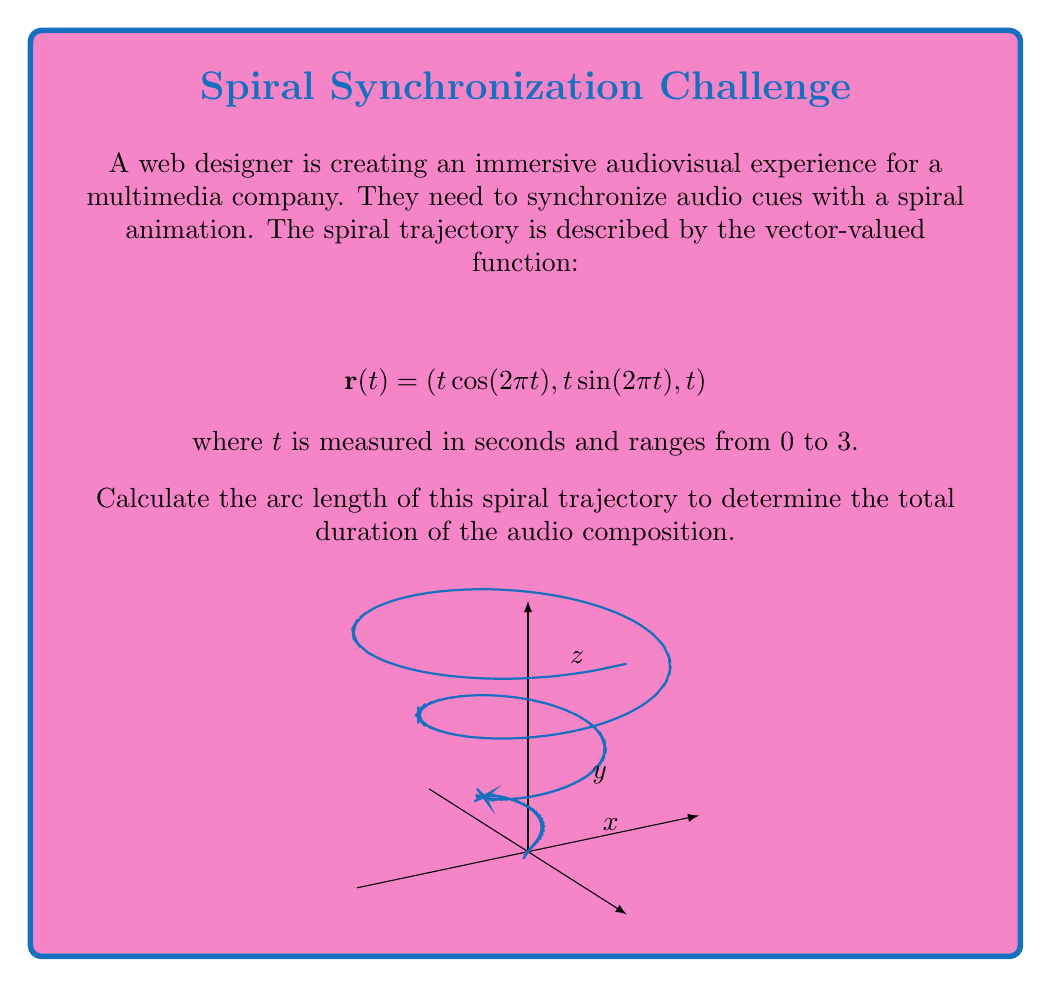Show me your answer to this math problem. To compute the arc length of a vector-valued function, we use the formula:

$$L = \int_a^b \left|\left|\frac{d\mathbf{r}}{dt}\right|\right| dt$$

where $\frac{d\mathbf{r}}{dt}$ is the derivative of the vector-valued function.

Step 1: Calculate $\frac{d\mathbf{r}}{dt}$
$$\frac{d\mathbf{r}}{dt} = (\cos(2\pi t) - 2\pi t \sin(2\pi t), \sin(2\pi t) + 2\pi t \cos(2\pi t), 1)$$

Step 2: Calculate $\left|\left|\frac{d\mathbf{r}}{dt}\right|\right|$
$$\left|\left|\frac{d\mathbf{r}}{dt}\right|\right| = \sqrt{(\cos(2\pi t) - 2\pi t \sin(2\pi t))^2 + (\sin(2\pi t) + 2\pi t \cos(2\pi t))^2 + 1^2}$$

Step 3: Simplify the expression under the square root
$$\left|\left|\frac{d\mathbf{r}}{dt}\right|\right| = \sqrt{\cos^2(2\pi t) - 4\pi t \cos(2\pi t)\sin(2\pi t) + 4\pi^2 t^2 \sin^2(2\pi t) + \sin^2(2\pi t) + 4\pi t \cos(2\pi t)\sin(2\pi t) + 4\pi^2 t^2 \cos^2(2\pi t) + 1}$$

$$= \sqrt{\cos^2(2\pi t) + \sin^2(2\pi t) + 4\pi^2 t^2 (\sin^2(2\pi t) + \cos^2(2\pi t)) + 1}$$

$$= \sqrt{1 + 4\pi^2 t^2 + 1} = \sqrt{4\pi^2 t^2 + 2}$$

Step 4: Set up the integral
$$L = \int_0^3 \sqrt{4\pi^2 t^2 + 2} dt$$

Step 5: This integral doesn't have an elementary antiderivative, so we need to use numerical integration methods to approximate the result. Using a computer algebra system or numerical integration tool, we can calculate:

$$L \approx 14.7867$$

Therefore, the arc length of the spiral trajectory is approximately 14.7867 units.
Answer: 14.7867 units 